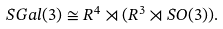<formula> <loc_0><loc_0><loc_500><loc_500>S G a l ( 3 ) \cong R ^ { 4 } \rtimes ( R ^ { 3 } \rtimes S O ( 3 ) ) .</formula> 